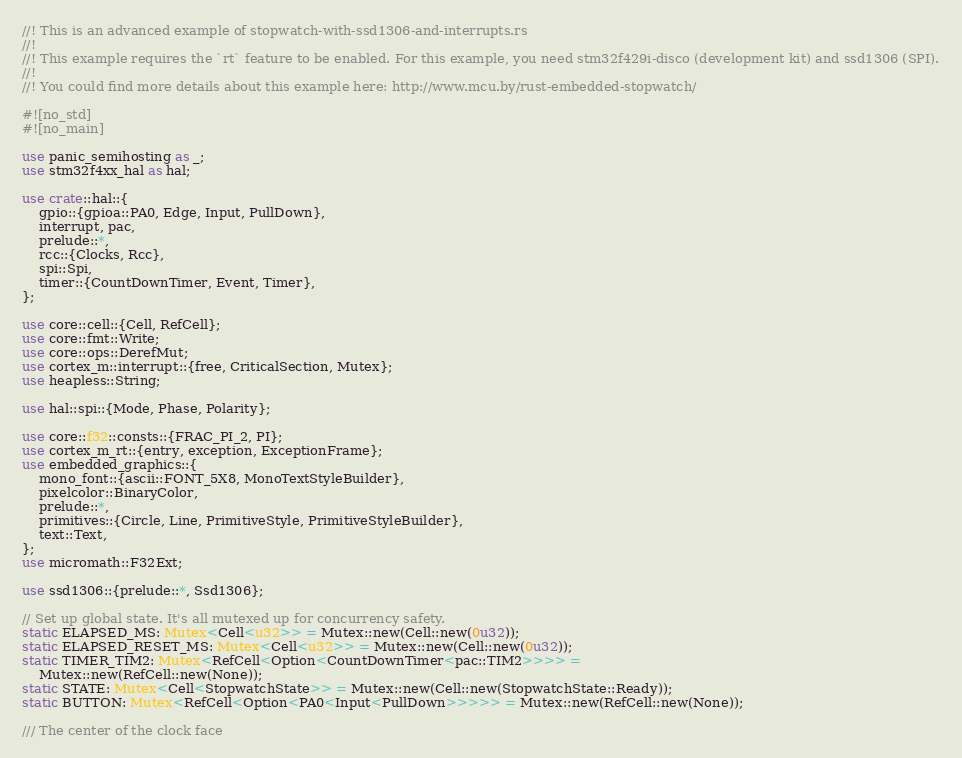<code> <loc_0><loc_0><loc_500><loc_500><_Rust_>//! This is an advanced example of stopwatch-with-ssd1306-and-interrupts.rs
//!
//! This example requires the `rt` feature to be enabled. For this example, you need stm32f429i-disco (development kit) and ssd1306 (SPI).
//!
//! You could find more details about this example here: http://www.mcu.by/rust-embedded-stopwatch/

#![no_std]
#![no_main]

use panic_semihosting as _;
use stm32f4xx_hal as hal;

use crate::hal::{
    gpio::{gpioa::PA0, Edge, Input, PullDown},
    interrupt, pac,
    prelude::*,
    rcc::{Clocks, Rcc},
    spi::Spi,
    timer::{CountDownTimer, Event, Timer},
};

use core::cell::{Cell, RefCell};
use core::fmt::Write;
use core::ops::DerefMut;
use cortex_m::interrupt::{free, CriticalSection, Mutex};
use heapless::String;

use hal::spi::{Mode, Phase, Polarity};

use core::f32::consts::{FRAC_PI_2, PI};
use cortex_m_rt::{entry, exception, ExceptionFrame};
use embedded_graphics::{
    mono_font::{ascii::FONT_5X8, MonoTextStyleBuilder},
    pixelcolor::BinaryColor,
    prelude::*,
    primitives::{Circle, Line, PrimitiveStyle, PrimitiveStyleBuilder},
    text::Text,
};
use micromath::F32Ext;

use ssd1306::{prelude::*, Ssd1306};

// Set up global state. It's all mutexed up for concurrency safety.
static ELAPSED_MS: Mutex<Cell<u32>> = Mutex::new(Cell::new(0u32));
static ELAPSED_RESET_MS: Mutex<Cell<u32>> = Mutex::new(Cell::new(0u32));
static TIMER_TIM2: Mutex<RefCell<Option<CountDownTimer<pac::TIM2>>>> =
    Mutex::new(RefCell::new(None));
static STATE: Mutex<Cell<StopwatchState>> = Mutex::new(Cell::new(StopwatchState::Ready));
static BUTTON: Mutex<RefCell<Option<PA0<Input<PullDown>>>>> = Mutex::new(RefCell::new(None));

/// The center of the clock face</code> 